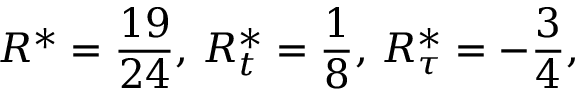<formula> <loc_0><loc_0><loc_500><loc_500>R ^ { * } = { \frac { 1 9 } { 2 4 } } , \, R _ { t } ^ { * } = { \frac { 1 } { 8 } } , \, R _ { \tau } ^ { * } = - { \frac { 3 } { 4 } } ,</formula> 